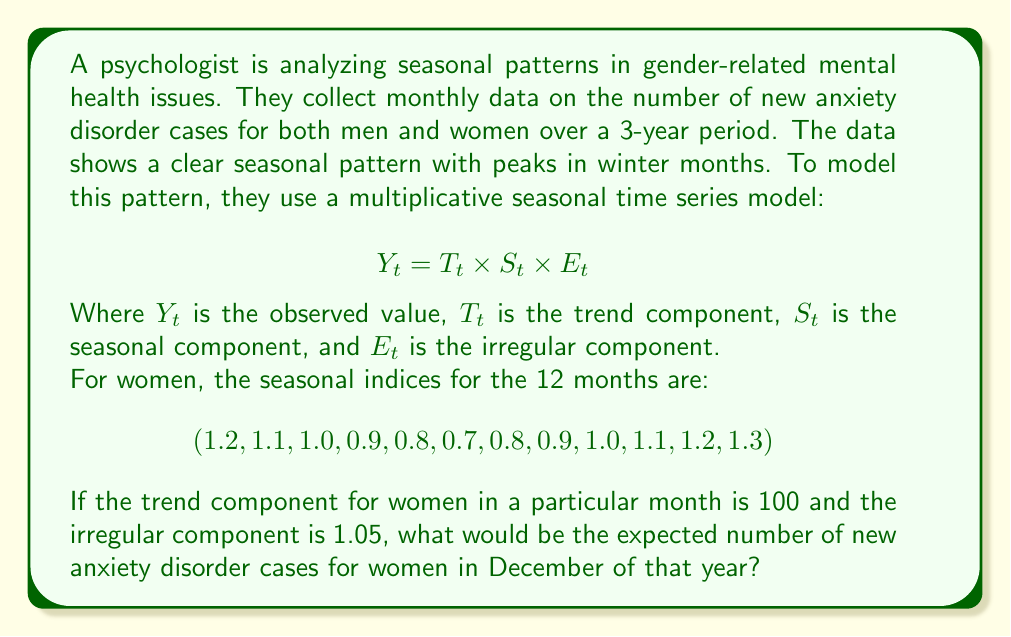Help me with this question. To solve this problem, we need to use the multiplicative seasonal time series model:

$$Y_t = T_t \times S_t \times E_t$$

We are given the following information:
1. $T_t$ (trend component) = 100
2. $E_t$ (irregular component) = 1.05
3. $S_t$ (seasonal component for December) = 1.3 (last value in the given seasonal indices)

Now, let's substitute these values into the equation:

$$Y_t = 100 \times 1.3 \times 1.05$$

Calculating step by step:
1. First, multiply the trend component and seasonal component:
   $$100 \times 1.3 = 130$$

2. Then, multiply the result by the irregular component:
   $$130 \times 1.05 = 136.5$$

Therefore, the expected number of new anxiety disorder cases for women in December of that year would be 136.5.

Note: In practice, we would typically round this to the nearest whole number, as we can't have a fractional number of cases. However, the exact calculated value is often kept for further analysis or comparisons.
Answer: 136.5 cases 